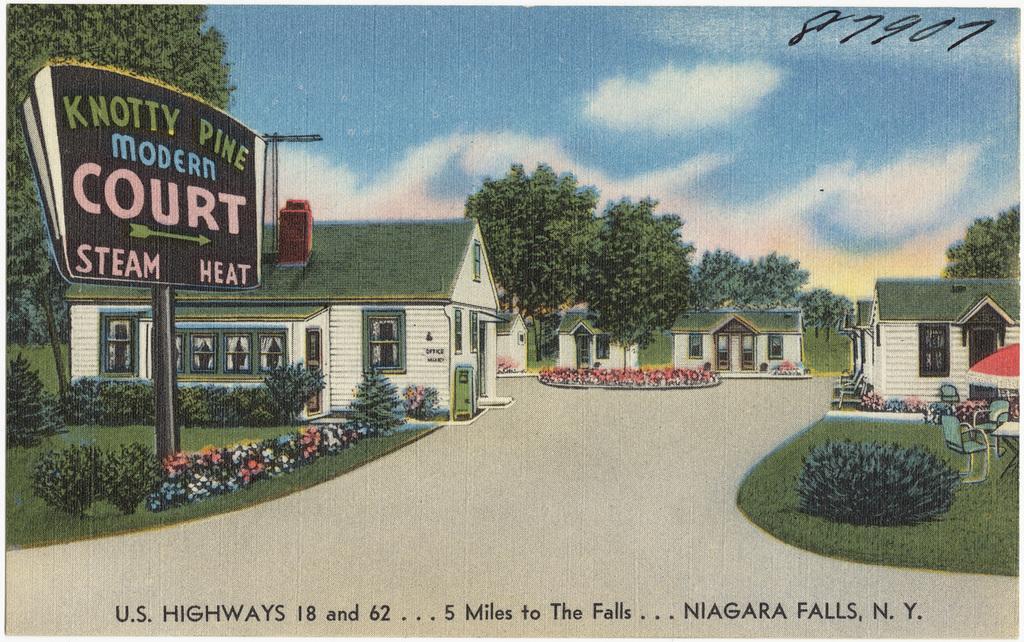Describe this image in one or two sentences. By seeing this image we can say it is a poster in which houses, trees and a board is there. 